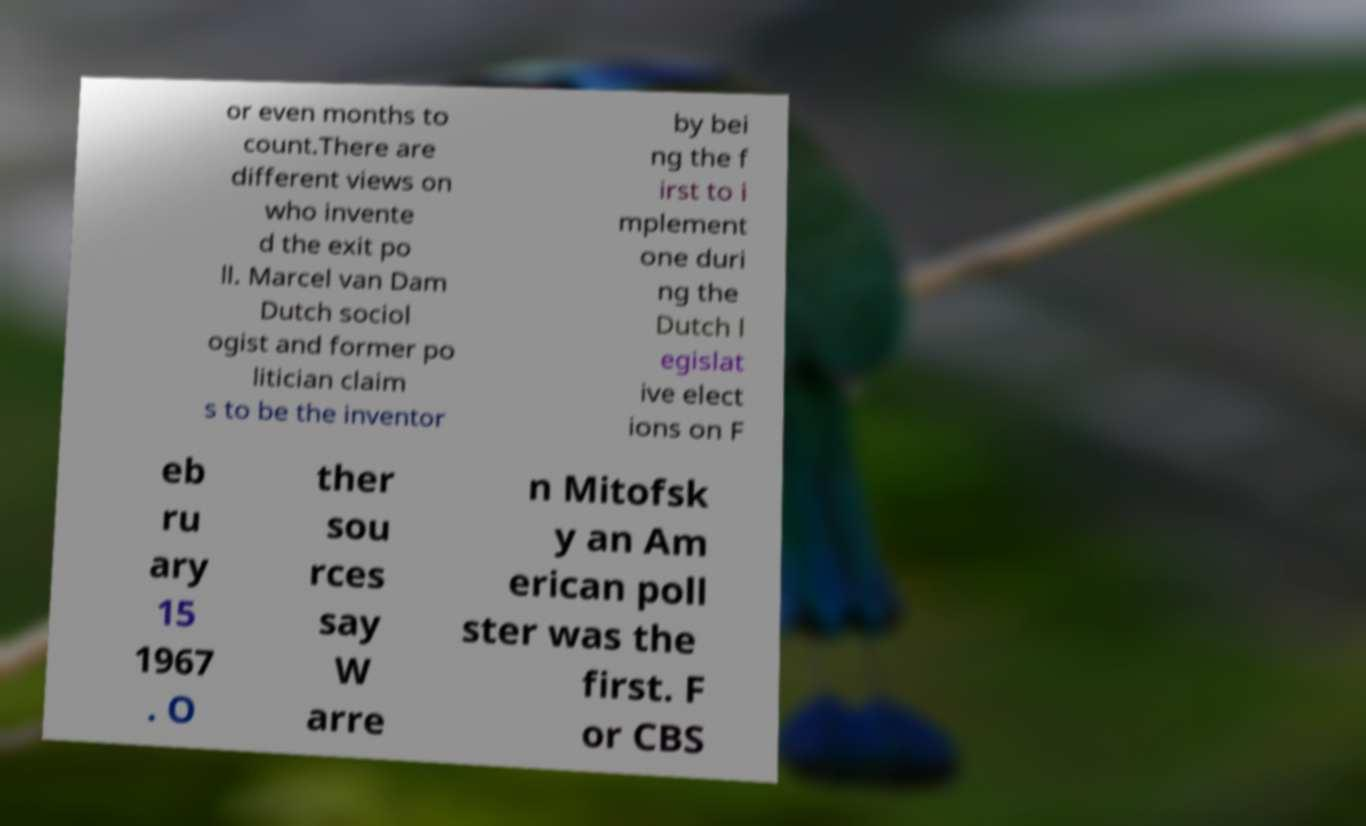Can you read and provide the text displayed in the image?This photo seems to have some interesting text. Can you extract and type it out for me? or even months to count.There are different views on who invente d the exit po ll. Marcel van Dam Dutch sociol ogist and former po litician claim s to be the inventor by bei ng the f irst to i mplement one duri ng the Dutch l egislat ive elect ions on F eb ru ary 15 1967 . O ther sou rces say W arre n Mitofsk y an Am erican poll ster was the first. F or CBS 